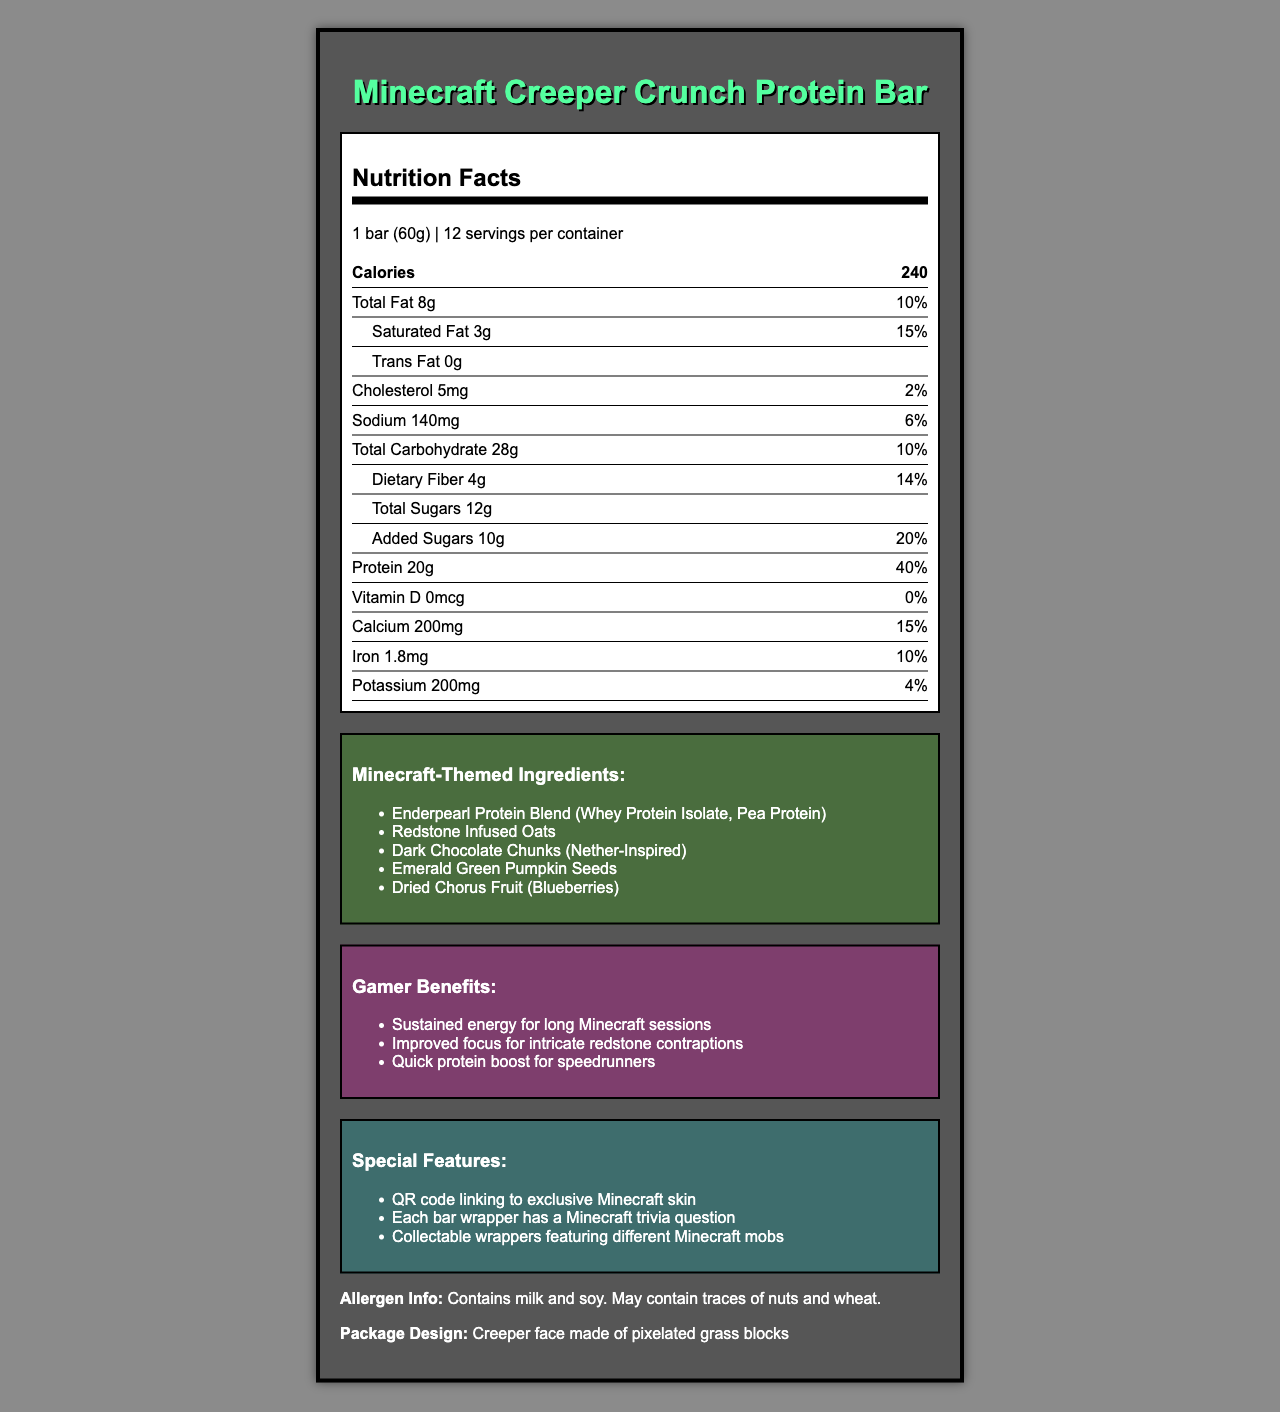what is the serving size of the Minecraft Creeper Crunch Protein Bar? The serving size is stated in the document under the serving size section.
Answer: 1 bar (60g) how many bars are there in one container? The document mentions there are 12 servings per container.
Answer: 12 how much total fat is in one serving of the protein bar? According to the nutrition label, one serving contains 8g of total fat.
Answer: 8g how many calories are in one bar? The document specifies that each bar contains 240 calories.
Answer: 240 which ingredient is specifically mentioned as providing protein? The Minecraft-themed ingredients list includes "Enderpearl Protein Blend" which is a blend of whey protein isolate and pea protein.
Answer: Enderpearl Protein Blend (Whey Protein Isolate, Pea Protein) what special features does the packaging have? The document lists these special features in the special features section.
Answer: QR code linking to exclusive Minecraft skin, Each bar wrapper has a Minecraft trivia question, Collectable wrappers featuring different Minecraft mobs which of the following is not stated as a benefit for gamers?
A. Sustained energy for long Minecraft sessions
B. Improved focus for intricate redstone contraptions
C. Better sleep cycles
D. Quick protein boost for speedrunners The benefits listed in the document are sustained energy, improved focus, and a quick protein boost. Better sleep cycles is not mentioned.
Answer: C. Better sleep cycles how much protein does one bar provide? 
A. 10g
B. 15g
C. 20g
D. 25g According to the nutrition facts, one bar provides 20g of protein.
Answer: C. 20g does the product contain any added sugars? The nutrition label indicates that the bar contains 10g of added sugars.
Answer: Yes describe the main idea of the document. The document includes a detailed nutrition facts label, a list of ingredients inspired by Minecraft, specific benefits for gamers, and special features such as QR codes for exclusive content and collectable wrappers.
Answer: The document provides nutritional information, ingredients, and special features of the Minecraft Creeper Crunch Protein Bar, designed to offer specific benefits for gamers, with unique Minecraft-themed ingredients and packaging. is there any information about the manufacturing date? The document does not provide any details about the manufacturing date of the protein bars.
Answer: Not enough information 